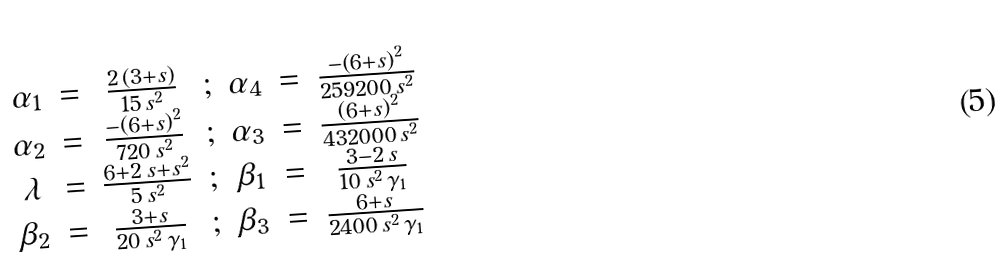Convert formula to latex. <formula><loc_0><loc_0><loc_500><loc_500>\begin{array} { c c c c c c c } \alpha _ { 1 } & = & { \frac { 2 \, \left ( 3 + s \right ) } { 1 5 \, s ^ { 2 } } } & ; & \alpha _ { 4 } & = & { \frac { - { \left ( 6 + s \right ) } ^ { 2 } } { 2 5 9 2 0 0 \, s ^ { 2 } } } \\ \alpha _ { 2 } & = & { \frac { - { \left ( 6 + s \right ) } ^ { 2 } } { 7 2 0 \, s ^ { 2 } } } & ; & \alpha _ { 3 } & = & { \frac { { \left ( 6 + s \right ) } ^ { 2 } } { 4 3 2 0 0 0 \, s ^ { 2 } } } \\ \lambda & = & { \frac { 6 + 2 \, s + s ^ { 2 } } { 5 \, s ^ { 2 } } } & ; & \beta _ { 1 } & = & { \frac { 3 - 2 \, s } { 1 0 \, s ^ { 2 } \, { { \gamma } _ { 1 } } } } \\ \beta _ { 2 } & = & { \frac { 3 + s } { 2 0 \, s ^ { 2 } \, { { \gamma } _ { 1 } } } } & ; & \beta _ { 3 } & = & { \frac { 6 + s } { 2 4 0 0 \, s ^ { 2 } \, { { \gamma } _ { 1 } } } } \\ \end{array}</formula> 